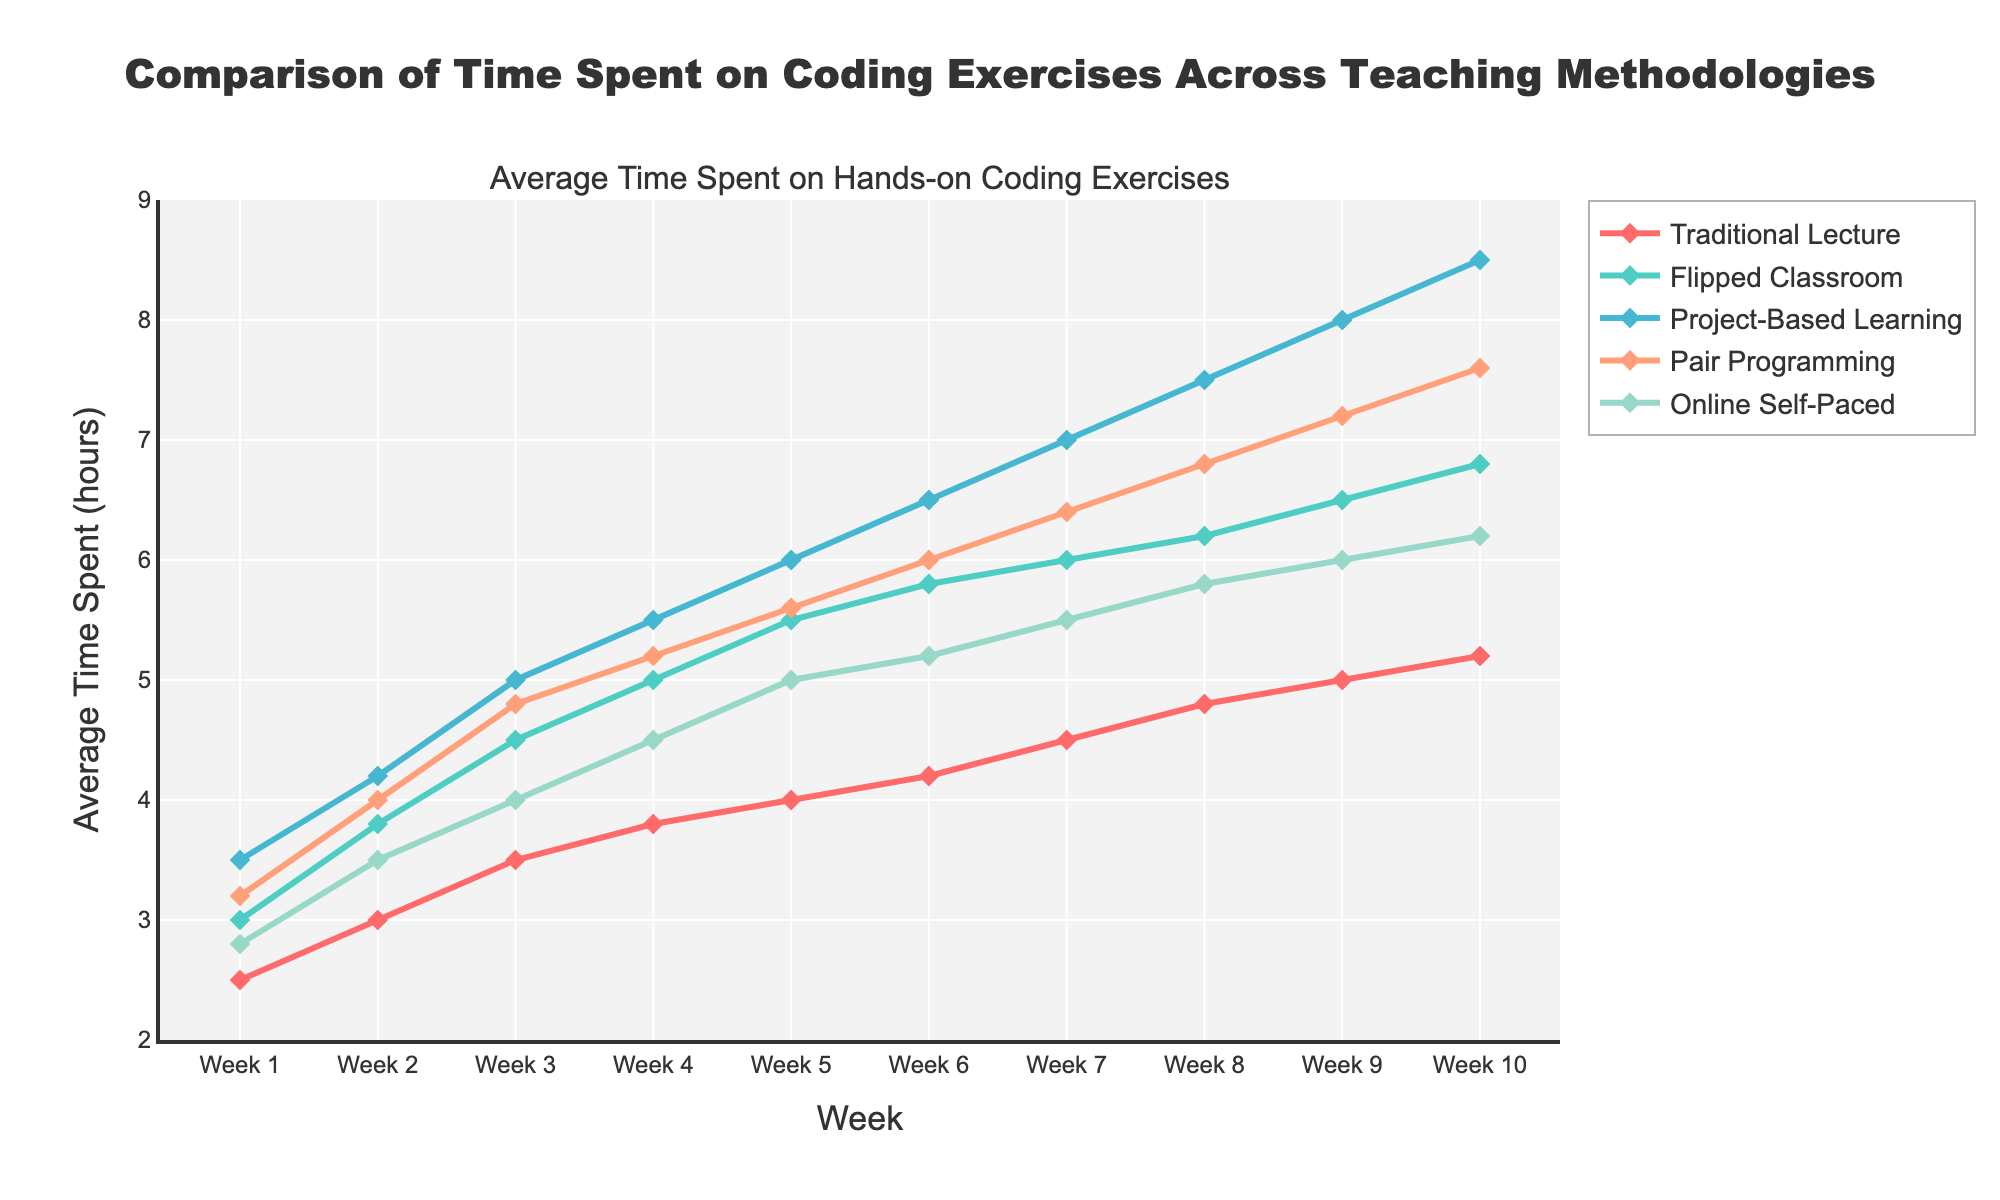What's the average time spent on hands-on coding exercises in Week 5 across all teaching methodologies? Sum the average times in Week 5: (4.0 + 5.5 + 6.0 + 5.6 + 5.0) and divide by the number of methods (5). Sum = 26.1, average = 26.1 / 5
Answer: 5.22 Which teaching method showed the greatest improvement in average time spent from Week 1 to Week 10? Calculate the difference in average time from Week 1 to Week 10 for each method and compare: Traditional Lecture (5.2 - 2.5 = 2.7), Flipped Classroom (6.8 - 3.0 = 3.8), Project-Based Learning (8.5 - 3.5 = 5.0), Pair Programming (7.6 - 3.2 = 4.4), Online Self-Paced (6.2 - 2.8 = 3.4). The greatest improvement is for Project-Based Learning.
Answer: Project-Based Learning What is the difference in average time spent between Flipped Classroom and Traditional Lecture in Week 7? Subtract the average time of Traditional Lecture in Week 7 from that of Flipped Classroom: 6.0 - 4.5 = 1.5
Answer: 1.5 Which teaching method had the lowest average time spent on coding exercises in Week 3? Compare the average times in Week 3: Traditional Lecture (3.5), Flipped Classroom (4.5), Project-Based Learning (5.0), Pair Programming (4.8), Online Self-Paced (4.0). The lowest is Traditional Lecture.
Answer: Traditional Lecture In which week did Pair Programming have the same average time spent on coding exercises as Project-Based Learning? Compare the average times of Pair Programming and Project-Based Learning week by week and find the week they are equal: Week 6 (6.0 for both).
Answer: Week 6 What teaching method had the highest average time spent on coding exercises in Week 4? Compare the average times in Week 4: Traditional Lecture (3.8), Flipped Classroom (5.0), Project-Based Learning (5.5), Pair Programming (5.2), Online Self-Paced (4.5). The highest is Project-Based Learning.
Answer: Project-Based Learning What's the average time spent on coding exercises across the teaching methodologies in Week 1 and Week 10? For Week 1: Sum the values (2.5 + 3.0 + 3.5 + 3.2 + 2.8) and divide by 5: Sum = 15.0, average = 3.0. For Week 10: Sum the values (5.2 + 6.8 + 8.5 + 7.6 + 6.2) and divide by 5: Sum = 34.3, average = 6.86.
Answer: 3.0, 6.86 Which teaching method had the most consistent increase in average time spent on coding exercises across the weeks? Assess the week-to-week increase for each teaching method: Traditional Lecture (incremental but smallest slope), Flipped Classroom (steady), Project-Based Learning (steady but highest), Pair Programming (consistent), Online Self-Paced (steady but small increment). The most consistent increase is seen in Pair Programming.
Answer: Pair Programming 